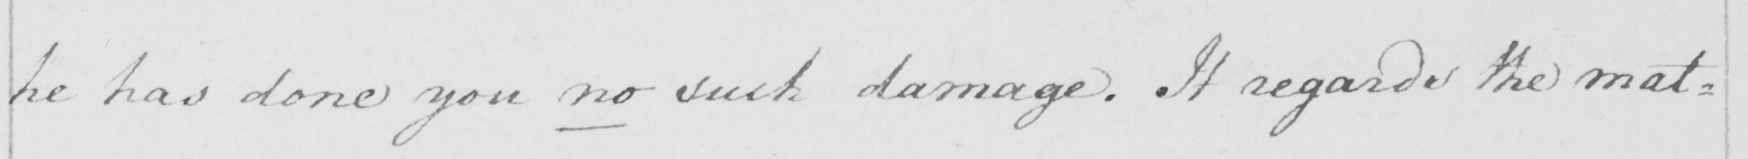Can you tell me what this handwritten text says? he has done you no such damage. It regards the mat= 